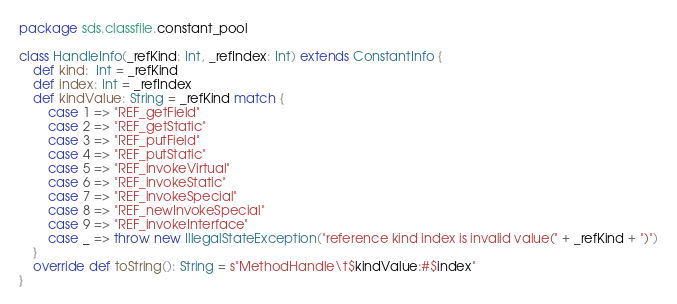Convert code to text. <code><loc_0><loc_0><loc_500><loc_500><_Scala_>package sds.classfile.constant_pool

class HandleInfo(_refKind: Int, _refIndex: Int) extends ConstantInfo {
    def kind:  Int = _refKind
    def index: Int = _refIndex
    def kindValue: String = _refKind match {
        case 1 => "REF_getField"
        case 2 => "REF_getStatic"
        case 3 => "REF_putField"
        case 4 => "REF_putStatic"
        case 5 => "REF_invokeVirtual"
        case 6 => "REF_invokeStatic"
        case 7 => "REF_invokeSpecial"
        case 8 => "REF_newInvokeSpecial"
        case 9 => "REF_invokeInterface"
        case _ => throw new IllegalStateException("reference kind index is invalid value(" + _refKind + ")")
    }
    override def toString(): String = s"MethodHandle\t$kindValue:#$index"
}</code> 